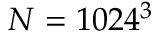Convert formula to latex. <formula><loc_0><loc_0><loc_500><loc_500>N = 1 0 2 4 ^ { 3 }</formula> 